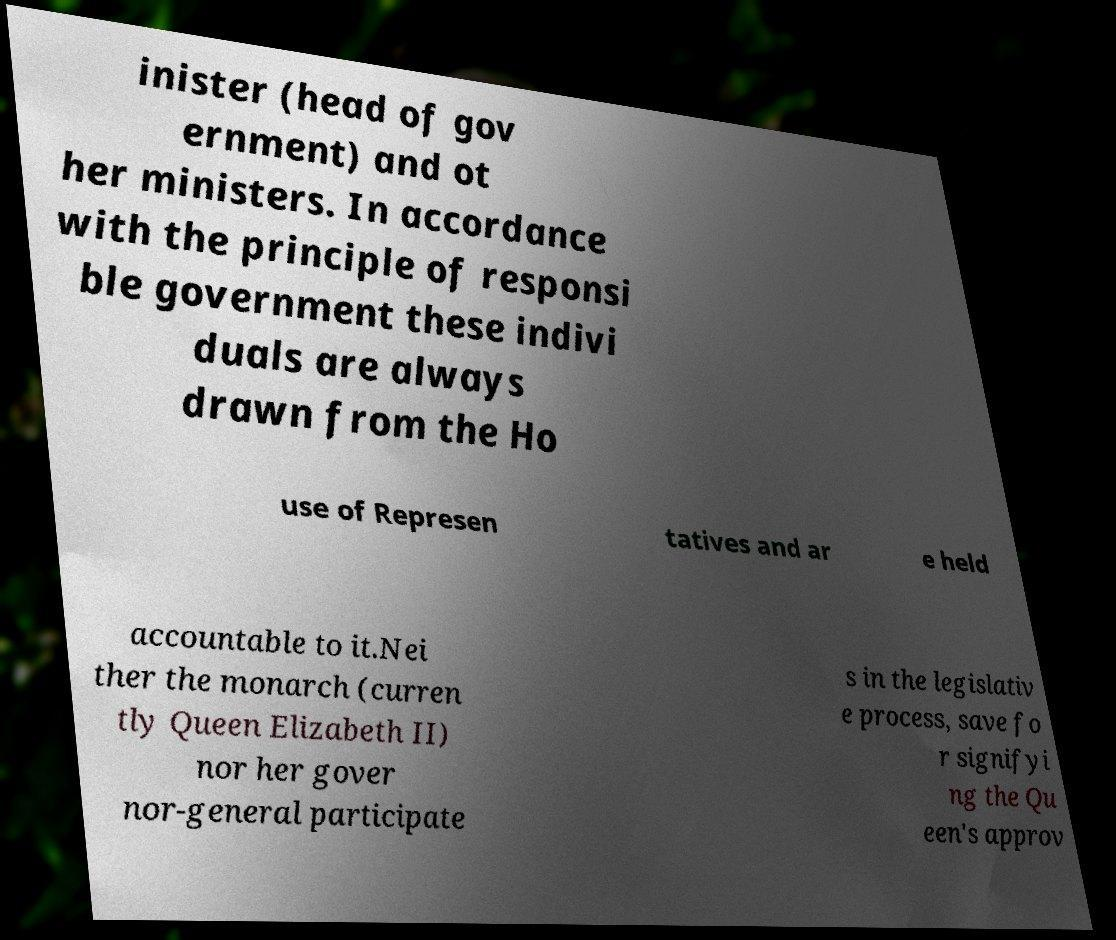I need the written content from this picture converted into text. Can you do that? inister (head of gov ernment) and ot her ministers. In accordance with the principle of responsi ble government these indivi duals are always drawn from the Ho use of Represen tatives and ar e held accountable to it.Nei ther the monarch (curren tly Queen Elizabeth II) nor her gover nor-general participate s in the legislativ e process, save fo r signifyi ng the Qu een's approv 